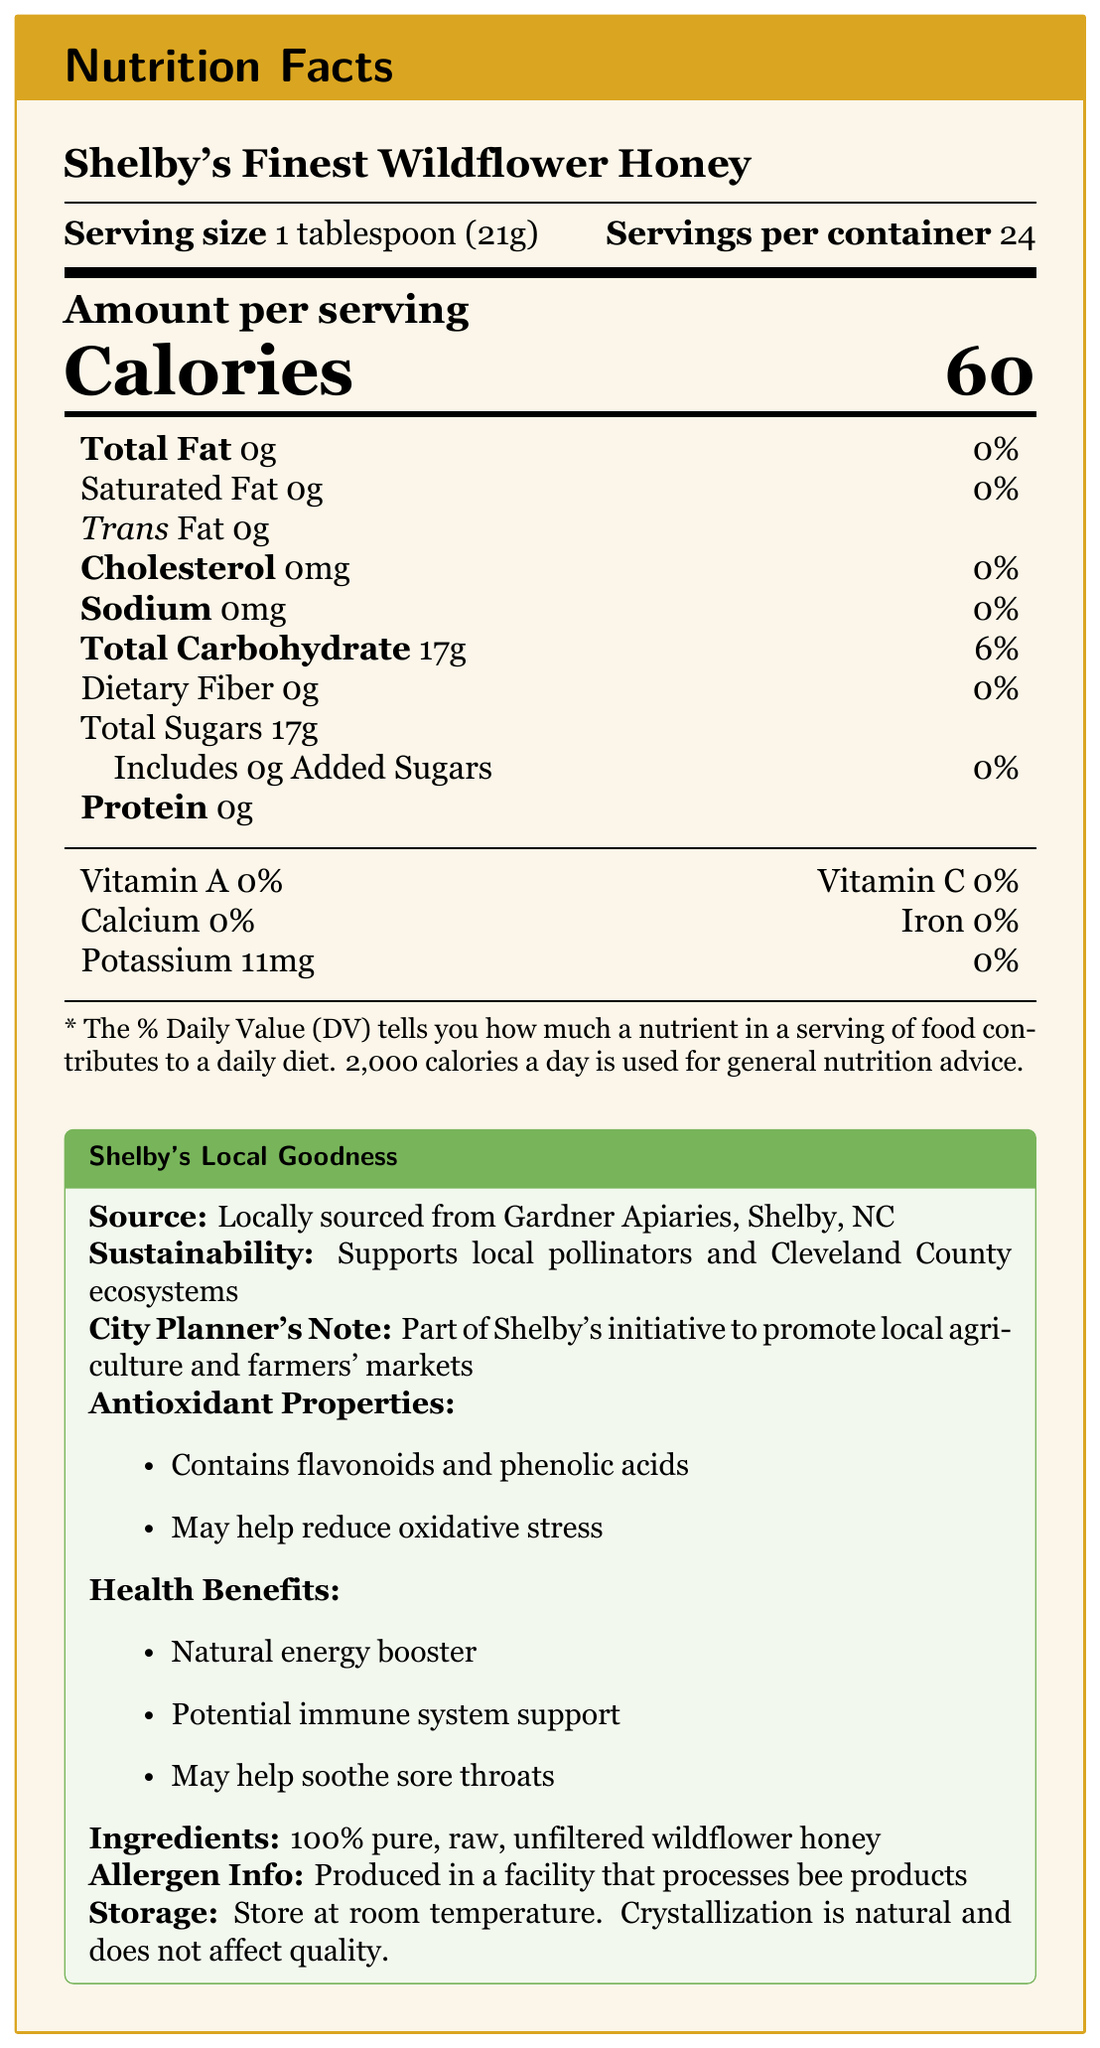who is the source of Shelby's Finest Wildflower Honey? The document indicates that the honey is locally sourced from Gardner Apiaries in Shelby, NC.
Answer: Gardner Apiaries what is the serving size of Shelby's Finest Wildflower Honey? The document lists the serving size as 1 tablespoon, which weighs 21 grams.
Answer: 1 tablespoon (21g) how many calories are there per serving of this honey? Under the "Amount per serving" section, the document indicates that each serving contains 60 calories.
Answer: 60 calories how many servings are there per container? The document lists that each container has 24 servings.
Answer: 24 name one health benefit of this honey. The document mentions that one of the health benefits of Shelby's Finest Wildflower Honey is that it serves as a natural energy booster.
Answer: Natural energy booster what vitamins are present in this honey? The document states 0% for vitamins A and C, indicating there are no measurable amounts of these vitamins.
Answer: None how much total carbohydrate is there per serving? A. 10g B. 17g C. 22g D. 5g The document lists 17g of total carbohydrate per serving.
Answer: B what percentage of the daily value does the sodium content contribute? A. 10% B. 5% C. 0% D. 1% The sodium content per serving is 0mg, contributing 0% to the daily value.
Answer: C is there any added sugar in this honey? The document indicates that there are 0g of added sugars per serving.
Answer: No does this product contain any dietary fiber? The document lists 0g of dietary fiber per serving.
Answer: No is this product processed in a facility that handles bee products? Under the "Allergen Info" section, the document mentions that it is produced in a facility that processes bee products.
Answer: Yes summarize the main idea of the document. The summary captures the essential points including nutritional content, health benefits, source, sustainability efforts, and additional consumer advice regarding storage and allergen information.
Answer: The document provides detailed Nutrition Facts for Shelby's Finest Wildflower Honey, highlighting its local sourcing, health benefits like natural energy boosting and soothing sore throats, as well as its antioxidant properties. It also includes storage instructions and notes on its contribution to sustainability and local agriculture initiatives. how much potassium does one serving of this honey provide? In the vitamins and minerals section, the document lists that each serving contains 11mg of potassium.
Answer: 11mg how is the honey described in terms of filtration and processing? The ingredient list specifies that the honey is 100% pure, raw, and unfiltered.
Answer: 100% pure, raw, unfiltered what is the sustainability note mentioned in the document? The document states that the product supports local pollinators and Cleveland County ecosystems under the "Sustainability" section.
Answer: Supports local pollinators and Cleveland County ecosystems is Shelby's Finest Wildflower Honey part of Shelby's initiative to promote local agriculture? The document includes a "City Planner's Note" mentioning that this product is part of Shelby's initiative to promote local agriculture and farmers' markets.
Answer: Yes how much total fat is in a serving of this honey? The document lists 0g of total fat per serving.
Answer: 0g does the honey contain any antioxidants? The document highlights that it contains flavonoids and phenolic acids, which may help reduce oxidative stress.
Answer: Yes where should you store Shelby's Finest Wildflower Honey? The "Storage" section advises to store the honey at room temperature.
Answer: Store at room temperature. how does the document advise handling crystallization in the honey? The "Storage" section notes that crystallization is a natural process and does not compromise the quality of the honey.
Answer: Crystallization is natural and does not affect quality. why is the honey considered part of Shelby's initiative? The document mentions it as part of the initiative but does not detail the specific reasons or criteria for inclusion.
Answer: Not enough information 